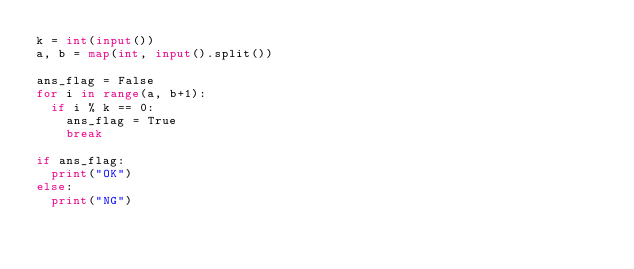<code> <loc_0><loc_0><loc_500><loc_500><_Python_>k = int(input())
a, b = map(int, input().split())

ans_flag = False
for i in range(a, b+1):
	if i % k == 0:
		ans_flag = True
		break

if ans_flag:
	print("OK")
else:
	print("NG")
</code> 